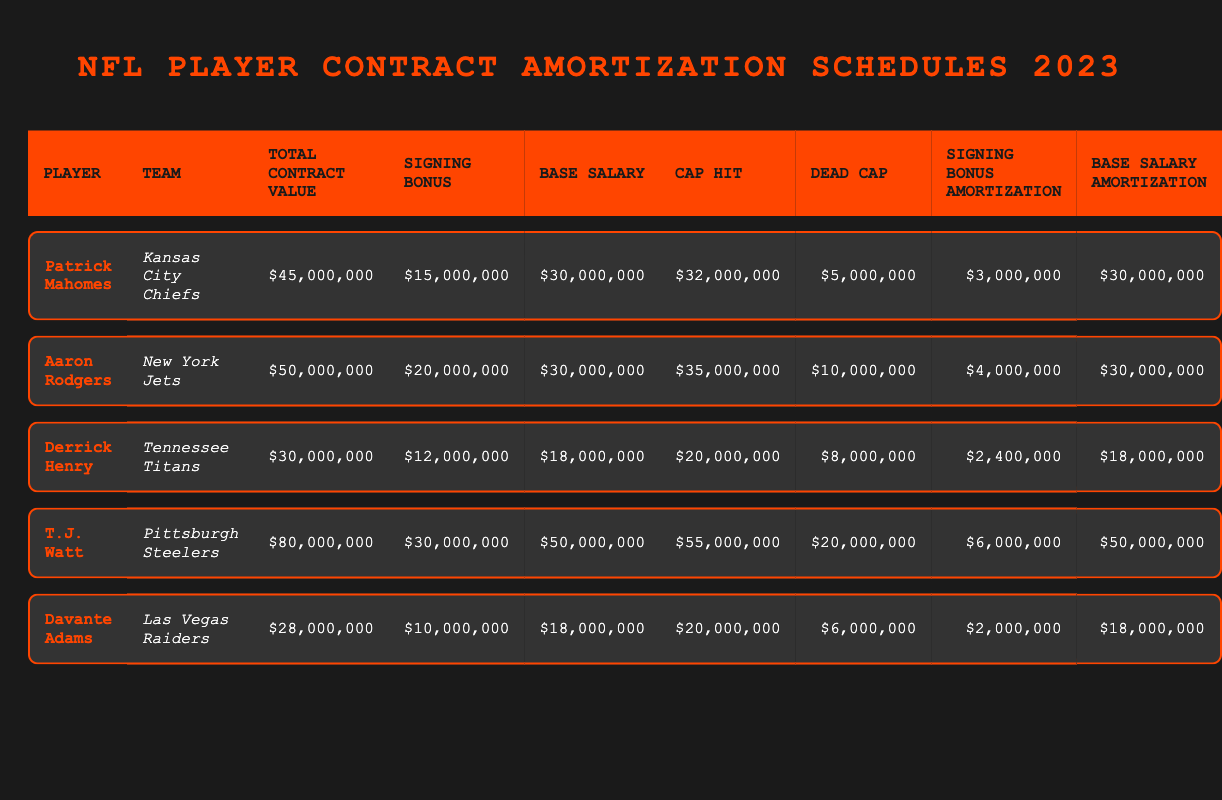What is the total contract value for Patrick Mahomes? From the table, I look for the row with Patrick Mahomes and the column labeled "Total Contract Value". The value listed is $45,000,000.
Answer: $45,000,000 Which player has the highest cap hit in 2023? I scan the "Cap Hit" column to identify which value is the largest. The highest value is for T.J. Watt, which is $55,000,000.
Answer: T.J. Watt How much is the signing bonus for Aaron Rodgers? In the row for Aaron Rodgers, I find the column labeled "Signing Bonus". The amount is $20,000,000.
Answer: $20,000,000 What is the average dead cap value among the listed players? First, I identify the dead cap values: $5,000,000 (Mahomes), $10,000,000 (Rodgers), $8,000,000 (Henry), $20,000,000 (Watt), $6,000,000 (Adams). Adding these gives a total of $49,000,000. Then, I divide this by the number of players (5) to get an average of $9,800,000.
Answer: $9,800,000 Is Davante Adams' cap hit greater than Derrick Henry's base salary? I check Davante Adams' cap hit, which is $20,000,000, and Derrick Henry's base salary, which is $18,000,000. Since $20,000,000 is greater than $18,000,000, the answer is yes.
Answer: Yes How much more is T.J. Watt's total contract value than Derrick Henry's? I find T.J. Watt's total contract value of $80,000,000 and Derrick Henry's at $30,000,000. To find the difference, I subtract: $80,000,000 - $30,000,000 = $50,000,000.
Answer: $50,000,000 Which player has a signing bonus amortization of $4,000,000? I look for the value $4,000,000 in the "Signing Bonus Amortization" column. It corresponds to Aaron Rodgers.
Answer: Aaron Rodgers What percentage of Patrick Mahomes' total contract value is his signing bonus? Patrick Mahomes' signing bonus is $15,000,000 and his total contract value is $45,000,000. To find the percentage, I calculate ($15,000,000 / $45,000,000) * 100, which gives approximately 33.33%.
Answer: 33.33% Which player has a base salary amortization of $18,000,000? I check the "Base Salary Amortization" column for the value $18,000,000. This corresponds to both Derrick Henry and Davante Adams.
Answer: Derrick Henry, Davante Adams 